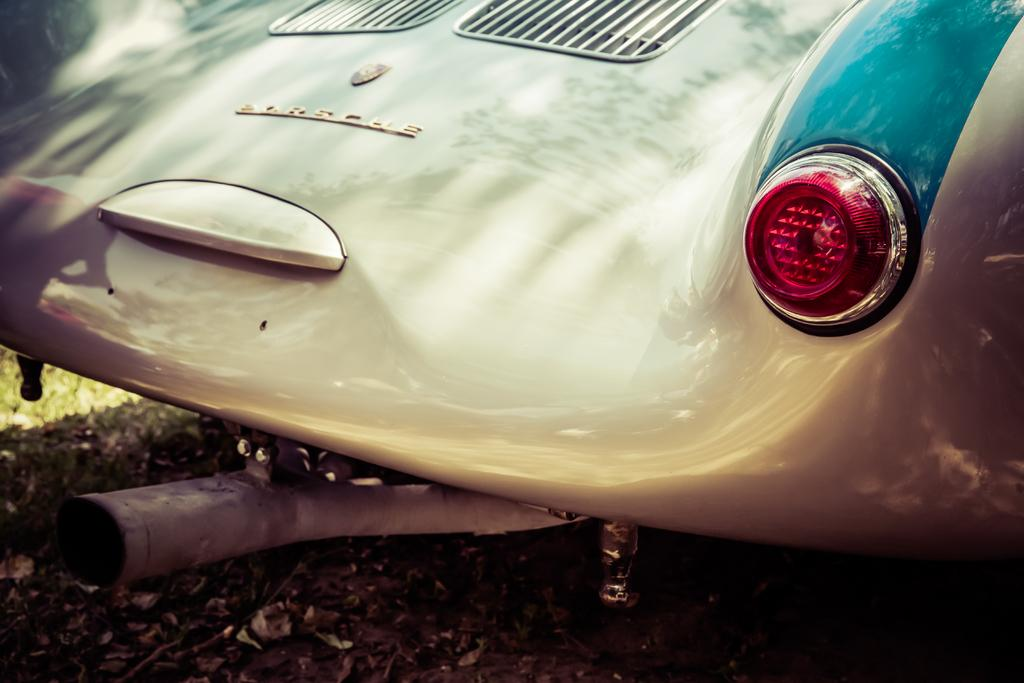What part of a vehicle is visible in the image? The back part of a vehicle is visible in the image. What can be seen on the vehicle? There is a logo and some text visible on the vehicle. What features are present on the vehicle? The vehicle has grills and a headlight. Are there any other objects present on the vehicle? Yes, other objects are present on the vehicle. What can be observed on the ground in the image? Leaves are visible on the ground. How many dogs are sitting on the vehicle's hood in the image? There are no dogs present in the image; it only shows the back part of a vehicle. 